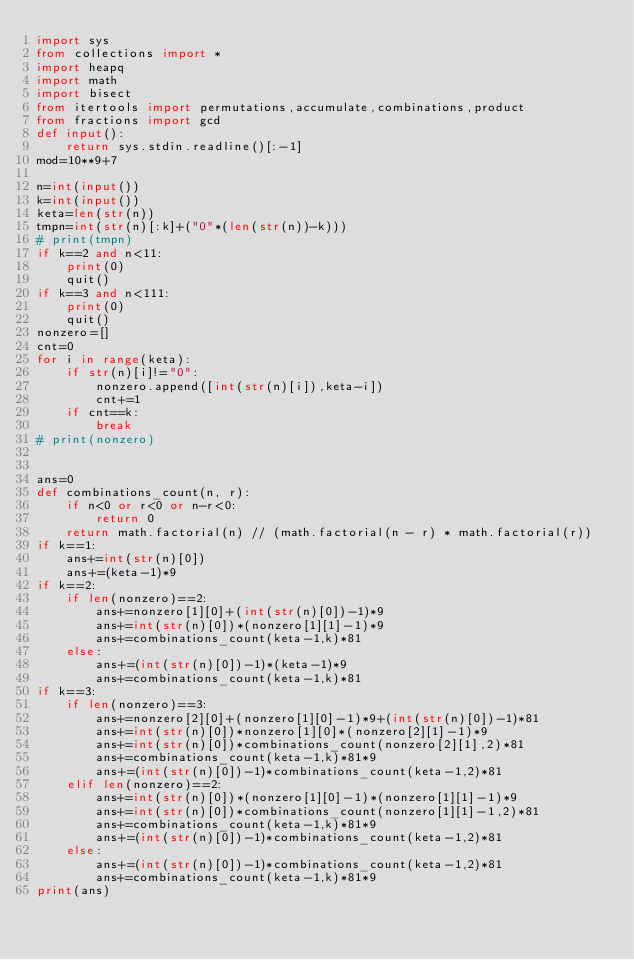Convert code to text. <code><loc_0><loc_0><loc_500><loc_500><_Python_>import sys
from collections import *
import heapq
import math
import bisect
from itertools import permutations,accumulate,combinations,product
from fractions import gcd
def input():
    return sys.stdin.readline()[:-1]
mod=10**9+7

n=int(input())
k=int(input())
keta=len(str(n))
tmpn=int(str(n)[:k]+("0"*(len(str(n))-k)))
# print(tmpn)
if k==2 and n<11:
    print(0)
    quit()
if k==3 and n<111:
    print(0)
    quit()
nonzero=[]
cnt=0
for i in range(keta):
    if str(n)[i]!="0":
        nonzero.append([int(str(n)[i]),keta-i])
        cnt+=1
    if cnt==k:
        break
# print(nonzero)
    

ans=0
def combinations_count(n, r):
    if n<0 or r<0 or n-r<0:
        return 0
    return math.factorial(n) // (math.factorial(n - r) * math.factorial(r))
if k==1:
    ans+=int(str(n)[0])
    ans+=(keta-1)*9
if k==2:
    if len(nonzero)==2:
        ans+=nonzero[1][0]+(int(str(n)[0])-1)*9
        ans+=int(str(n)[0])*(nonzero[1][1]-1)*9
        ans+=combinations_count(keta-1,k)*81
    else:
        ans+=(int(str(n)[0])-1)*(keta-1)*9
        ans+=combinations_count(keta-1,k)*81
if k==3:
    if len(nonzero)==3:
        ans+=nonzero[2][0]+(nonzero[1][0]-1)*9+(int(str(n)[0])-1)*81
        ans+=int(str(n)[0])*nonzero[1][0]*(nonzero[2][1]-1)*9
        ans+=int(str(n)[0])*combinations_count(nonzero[2][1],2)*81
        ans+=combinations_count(keta-1,k)*81*9
        ans+=(int(str(n)[0])-1)*combinations_count(keta-1,2)*81
    elif len(nonzero)==2:
        ans+=int(str(n)[0])*(nonzero[1][0]-1)*(nonzero[1][1]-1)*9
        ans+=int(str(n)[0])*combinations_count(nonzero[1][1]-1,2)*81
        ans+=combinations_count(keta-1,k)*81*9
        ans+=(int(str(n)[0])-1)*combinations_count(keta-1,2)*81
    else:
        ans+=(int(str(n)[0])-1)*combinations_count(keta-1,2)*81
        ans+=combinations_count(keta-1,k)*81*9
print(ans)</code> 